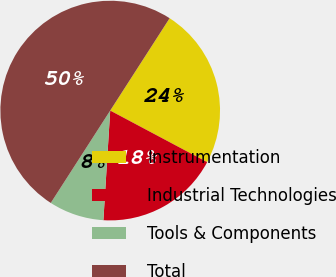Convert chart to OTSL. <chart><loc_0><loc_0><loc_500><loc_500><pie_chart><fcel>Instrumentation<fcel>Industrial Technologies<fcel>Tools & Components<fcel>Total<nl><fcel>23.68%<fcel>18.21%<fcel>8.11%<fcel>50.0%<nl></chart> 